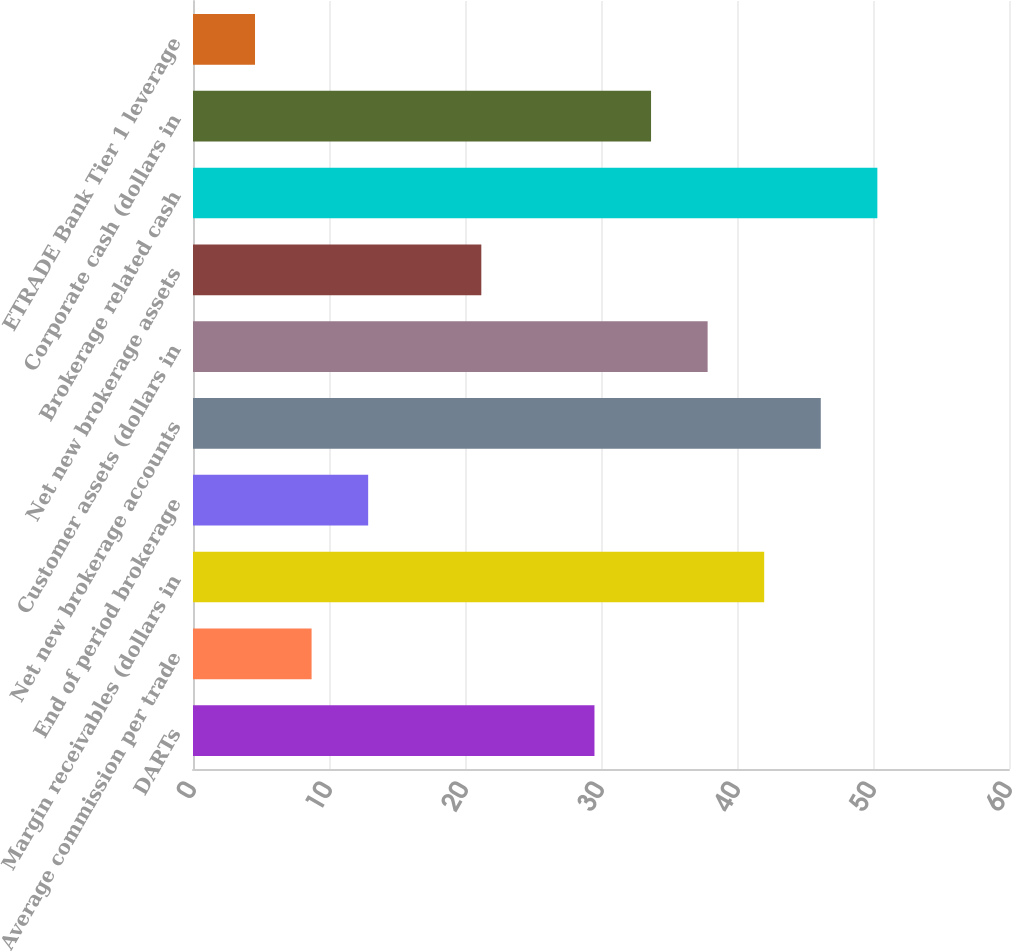Convert chart to OTSL. <chart><loc_0><loc_0><loc_500><loc_500><bar_chart><fcel>DARTs<fcel>Average commission per trade<fcel>Margin receivables (dollars in<fcel>End of period brokerage<fcel>Net new brokerage accounts<fcel>Customer assets (dollars in<fcel>Net new brokerage assets<fcel>Brokerage related cash<fcel>Corporate cash (dollars in<fcel>ETRADE Bank Tier 1 leverage<nl><fcel>29.52<fcel>8.72<fcel>42<fcel>12.88<fcel>46.16<fcel>37.84<fcel>21.2<fcel>50.32<fcel>33.68<fcel>4.56<nl></chart> 